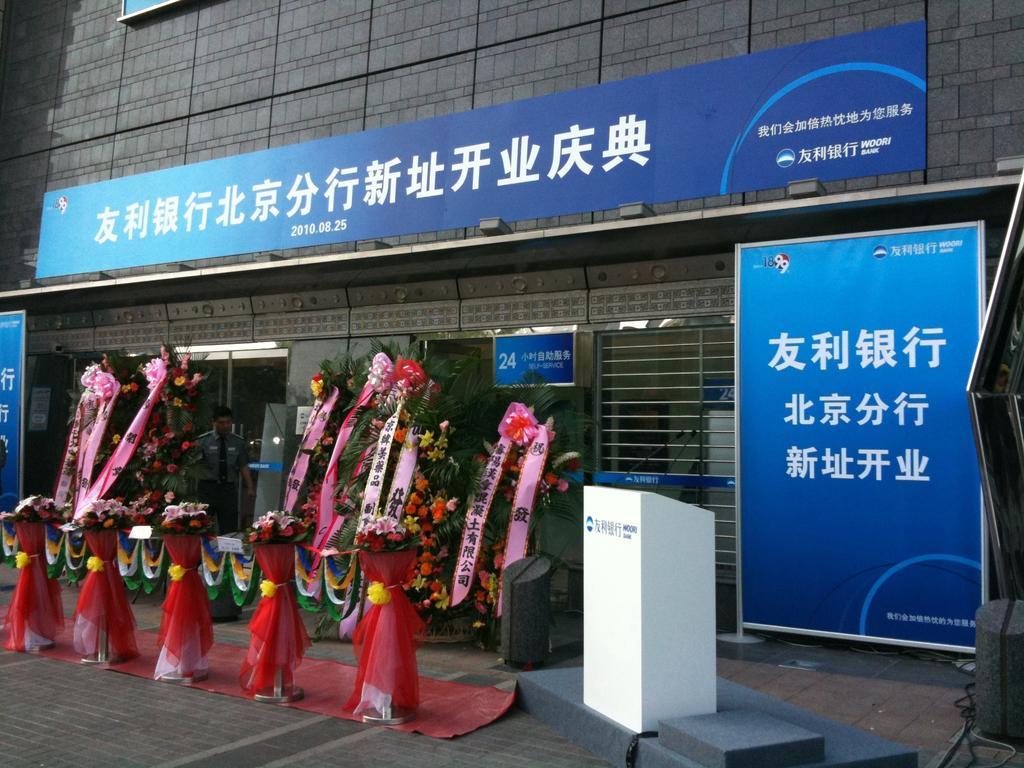Could you give a brief overview of what you see in this image? In this image I can see many flower bouquets and some decorative objects. To the tight I can see the podium and the banner. To the left I can see an another podium. In the background I can see the person standing and there is a building with windows and the many boards. 